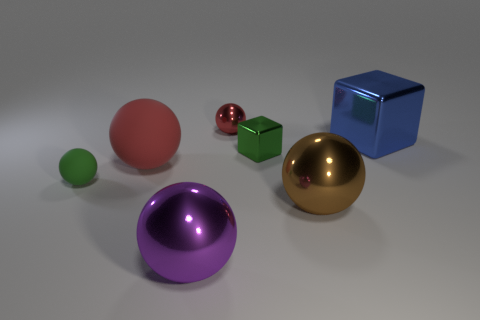Subtract all yellow balls. Subtract all green blocks. How many balls are left? 5 Add 2 gray shiny cubes. How many objects exist? 9 Subtract all balls. How many objects are left? 2 Subtract all big brown rubber balls. Subtract all big cubes. How many objects are left? 6 Add 6 big red objects. How many big red objects are left? 7 Add 2 large cubes. How many large cubes exist? 3 Subtract 1 brown balls. How many objects are left? 6 